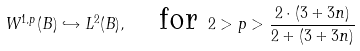<formula> <loc_0><loc_0><loc_500><loc_500>W ^ { 1 , p } ( B ) \hookrightarrow L ^ { 2 } ( B ) , \quad \text {for} \ 2 > p > \frac { 2 \cdot ( 3 + 3 n ) } { 2 + ( 3 + 3 n ) }</formula> 